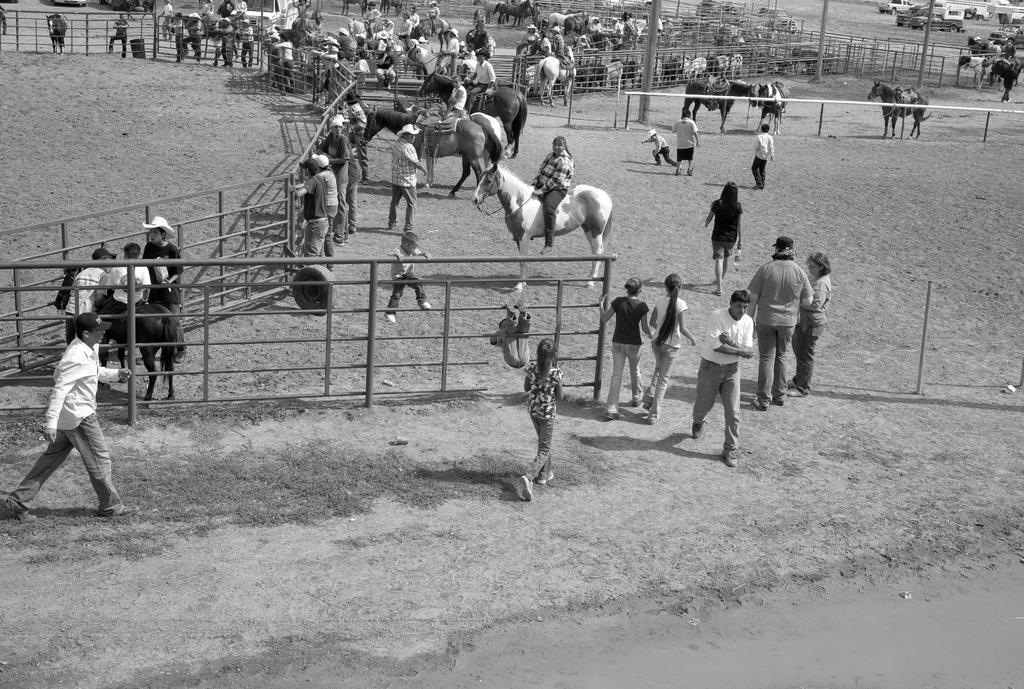In one or two sentences, can you explain what this image depicts? In this black and white picture few persons are walking on the land. Behind the fence a person is sitting on the horse. Beside him there is a person standing and he is wearing a cap. Left side there is a person walking and he is wearing a cap. Few persons are sitting on the horses. Top of the image there are few vehicles on the land. 